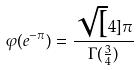<formula> <loc_0><loc_0><loc_500><loc_500>\varphi ( e ^ { - \pi } ) = \frac { \sqrt { [ } 4 ] { \pi } } { \Gamma ( \frac { 3 } { 4 } ) }</formula> 